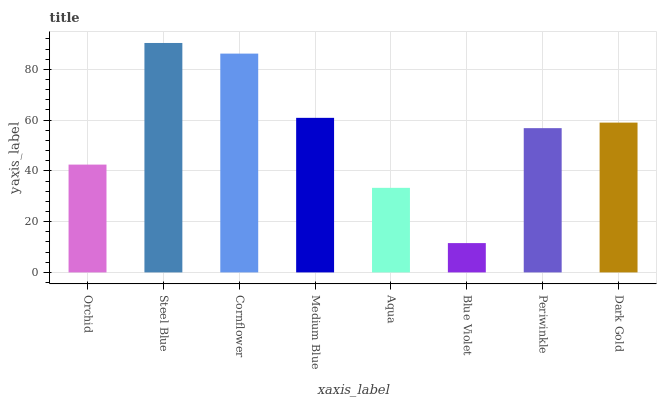Is Blue Violet the minimum?
Answer yes or no. Yes. Is Steel Blue the maximum?
Answer yes or no. Yes. Is Cornflower the minimum?
Answer yes or no. No. Is Cornflower the maximum?
Answer yes or no. No. Is Steel Blue greater than Cornflower?
Answer yes or no. Yes. Is Cornflower less than Steel Blue?
Answer yes or no. Yes. Is Cornflower greater than Steel Blue?
Answer yes or no. No. Is Steel Blue less than Cornflower?
Answer yes or no. No. Is Dark Gold the high median?
Answer yes or no. Yes. Is Periwinkle the low median?
Answer yes or no. Yes. Is Medium Blue the high median?
Answer yes or no. No. Is Aqua the low median?
Answer yes or no. No. 